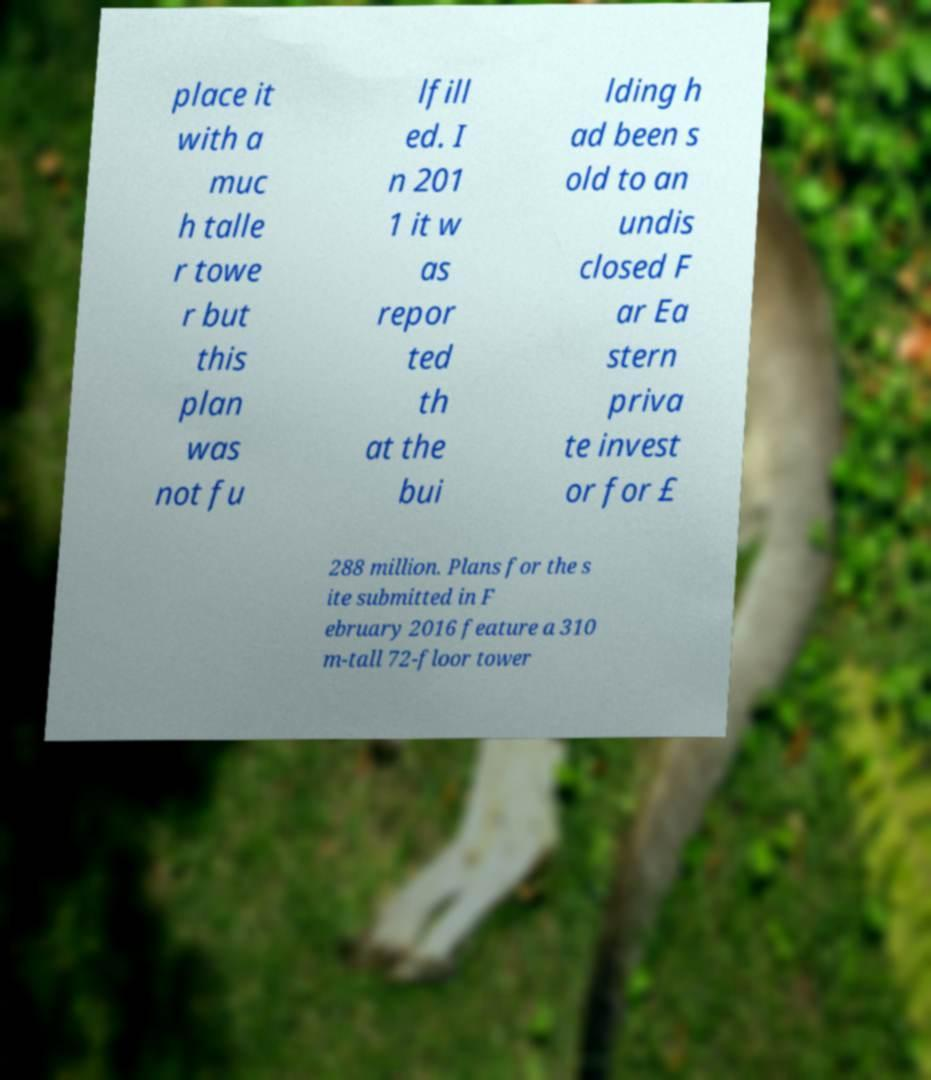Could you assist in decoding the text presented in this image and type it out clearly? place it with a muc h talle r towe r but this plan was not fu lfill ed. I n 201 1 it w as repor ted th at the bui lding h ad been s old to an undis closed F ar Ea stern priva te invest or for £ 288 million. Plans for the s ite submitted in F ebruary 2016 feature a 310 m-tall 72-floor tower 